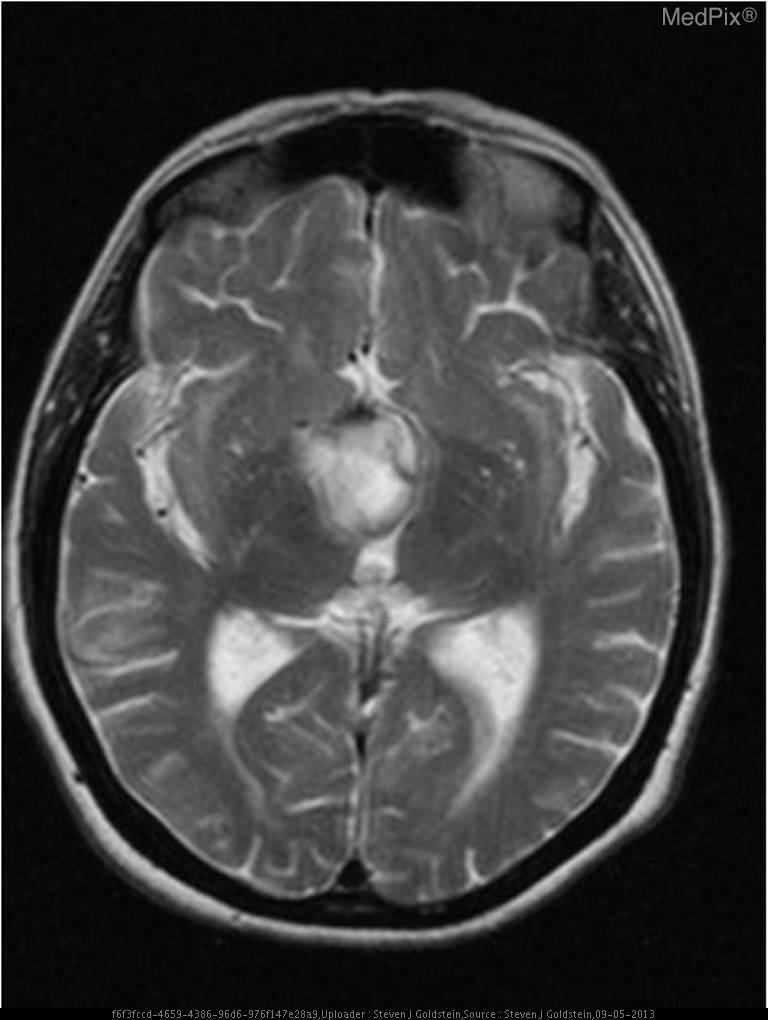Is this image normal?
Short answer required. No. Is there an abnormal lesion?
Answer briefly. Yes. Is there a mass?
Write a very short answer. Yes. Does the mass affect neighboring structure?
Give a very brief answer. Yes. Is there mass effect?
Write a very short answer. Yes. Where is the mass?
Give a very brief answer. Suprasellar cistern. Where is the mass located?
Give a very brief answer. Suprasellar cistern. 